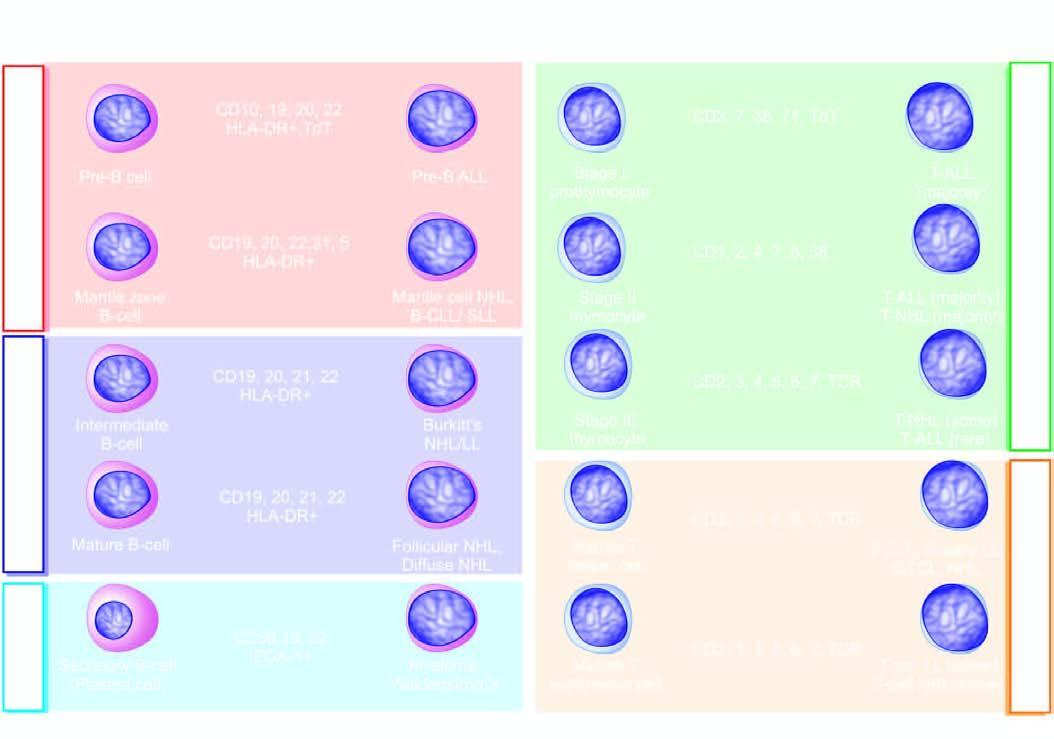re the congophilic areas correlated with normal immunophenotypic differentiation/maturation stages of b and t-cells in the bone marrow, lymphoid tissue, peripheral blood and thymus?
Answer the question using a single word or phrase. No 